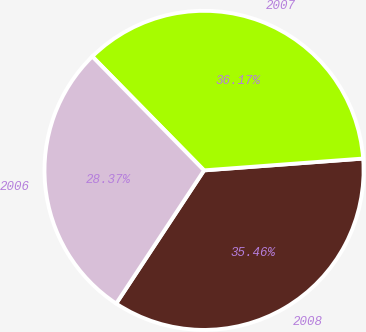<chart> <loc_0><loc_0><loc_500><loc_500><pie_chart><fcel>2008<fcel>2007<fcel>2006<nl><fcel>35.46%<fcel>36.17%<fcel>28.37%<nl></chart> 